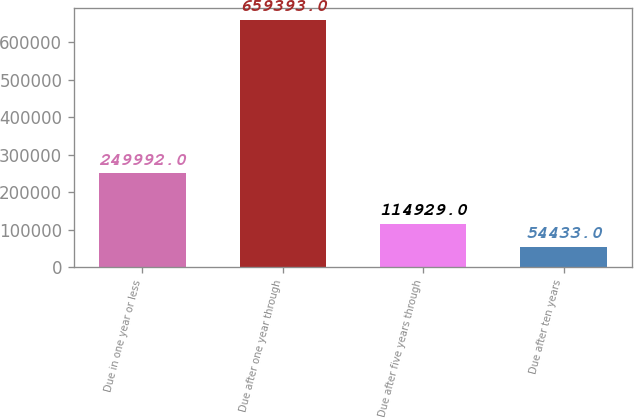Convert chart to OTSL. <chart><loc_0><loc_0><loc_500><loc_500><bar_chart><fcel>Due in one year or less<fcel>Due after one year through<fcel>Due after five years through<fcel>Due after ten years<nl><fcel>249992<fcel>659393<fcel>114929<fcel>54433<nl></chart> 